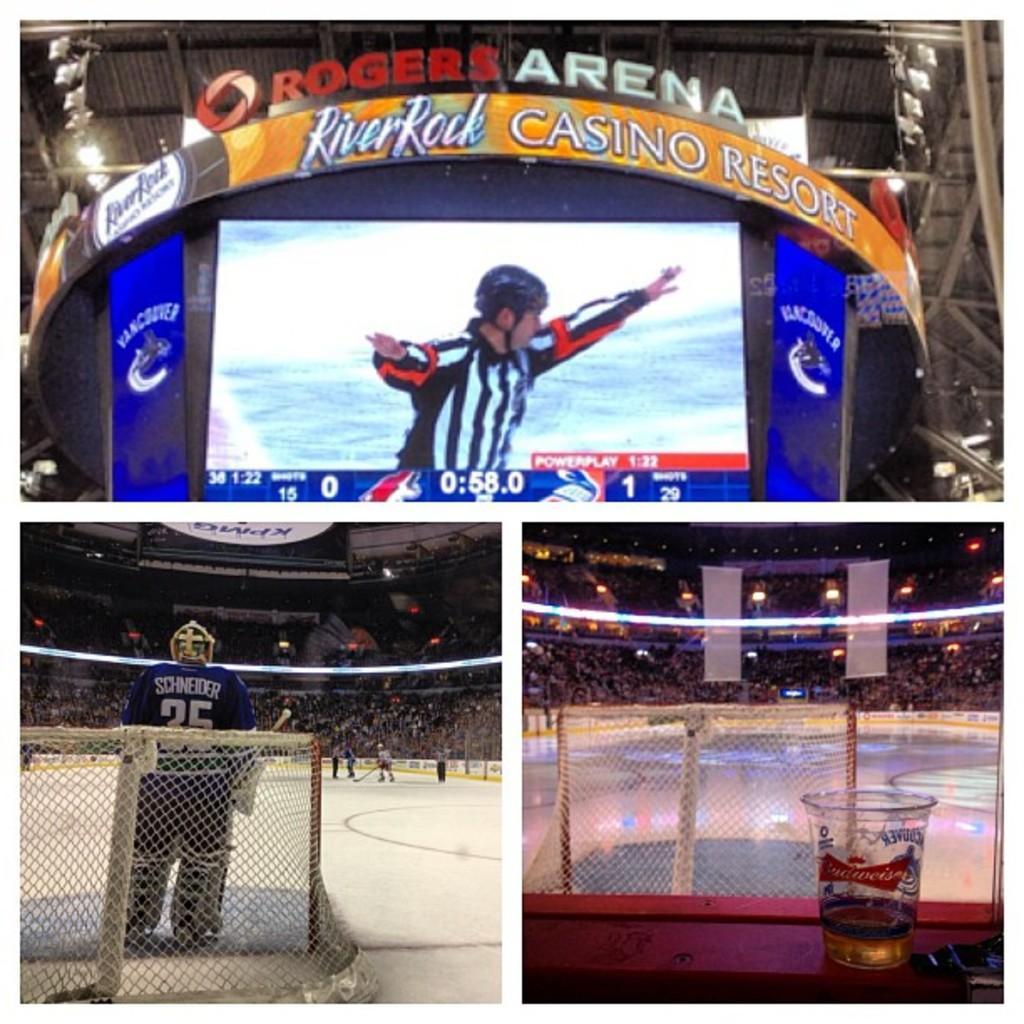Describe this image in one or two sentences. This is a collage image. Here I can see 3 pictures. In the top picture there is a screen. On the screen, I can see a person. Around there are some boards. On the boards I can see the text. In the bottom two pictures, I can see the stadium and stage and also there is net. In these images, I can see a crowd of people and few lights. 